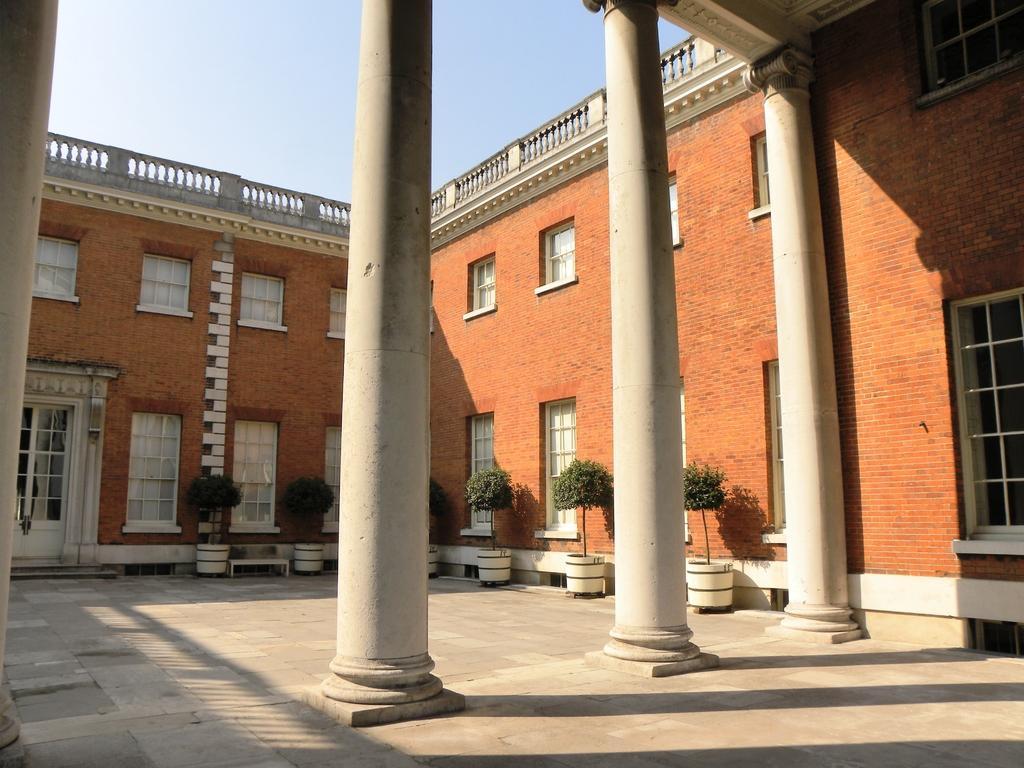Describe this image in one or two sentences. In this image, we can see a building. There are a few pillars and plants in pots. We can see the ground and the sky. 